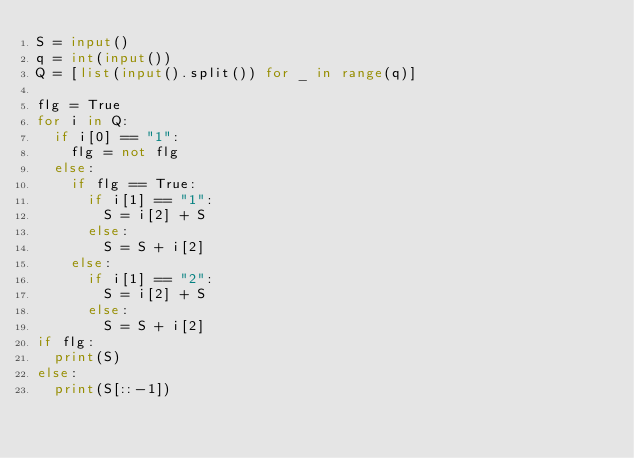Convert code to text. <code><loc_0><loc_0><loc_500><loc_500><_Python_>S = input()
q = int(input())
Q = [list(input().split()) for _ in range(q)]

flg = True
for i in Q:
  if i[0] == "1":
    flg = not flg
  else:
    if flg == True:
      if i[1] == "1":
        S = i[2] + S
      else:
        S = S + i[2]
    else:
      if i[1] == "2":
        S = i[2] + S
      else:
        S = S + i[2]
if flg:
  print(S)
else:
  print(S[::-1])

        </code> 